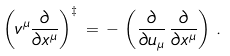Convert formula to latex. <formula><loc_0><loc_0><loc_500><loc_500>\left ( v ^ { \mu } \frac { \partial } { \partial x ^ { \mu } } \right ) ^ { \ddagger } \, = \, - \, \left ( \frac { \partial } { \partial u _ { \mu } } \, \frac { \partial } { \partial x ^ { \mu } } \right ) \, .</formula> 